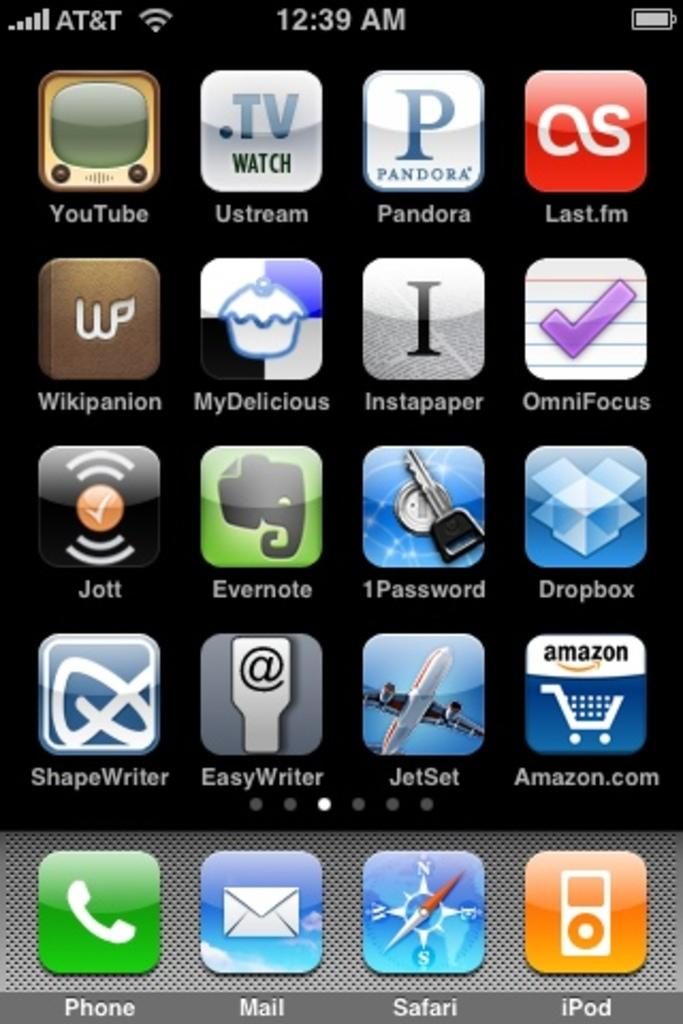<image>
Write a terse but informative summary of the picture. the main page of an iphone with icons for several apps like amazon and safari. 